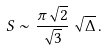<formula> <loc_0><loc_0><loc_500><loc_500>S \sim \frac { \pi \sqrt { 2 } } { \sqrt { 3 } } \, \sqrt { \Delta } \, .</formula> 